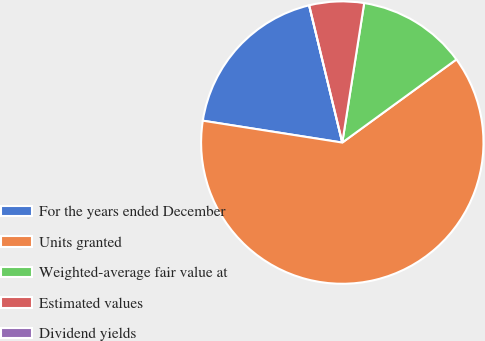Convert chart to OTSL. <chart><loc_0><loc_0><loc_500><loc_500><pie_chart><fcel>For the years ended December<fcel>Units granted<fcel>Weighted-average fair value at<fcel>Estimated values<fcel>Dividend yields<nl><fcel>18.75%<fcel>62.5%<fcel>12.5%<fcel>6.25%<fcel>0.0%<nl></chart> 